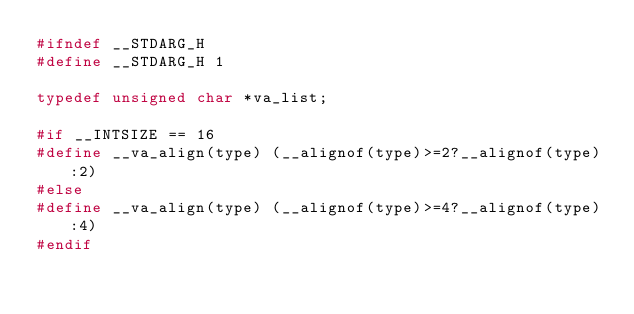<code> <loc_0><loc_0><loc_500><loc_500><_C_>#ifndef __STDARG_H
#define __STDARG_H 1

typedef unsigned char *va_list;

#if __INTSIZE == 16
#define __va_align(type) (__alignof(type)>=2?__alignof(type):2)
#else
#define __va_align(type) (__alignof(type)>=4?__alignof(type):4)
#endif
</code> 